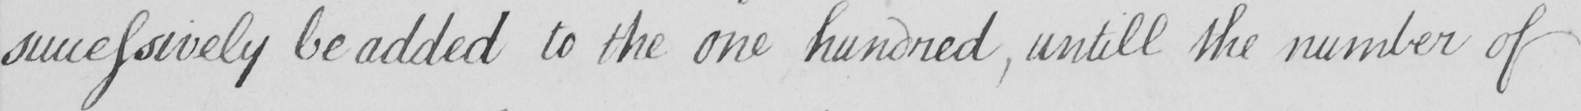What does this handwritten line say? successively be added to the one hundred , untill the number of 